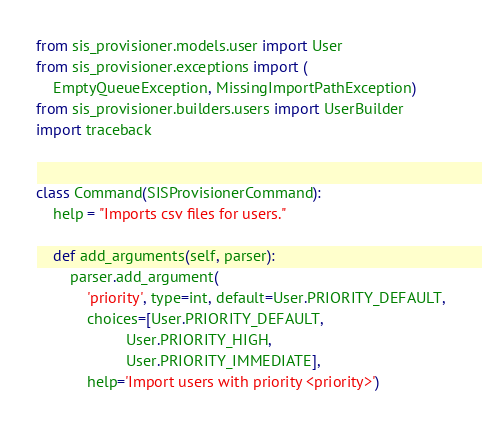<code> <loc_0><loc_0><loc_500><loc_500><_Python_>from sis_provisioner.models.user import User
from sis_provisioner.exceptions import (
    EmptyQueueException, MissingImportPathException)
from sis_provisioner.builders.users import UserBuilder
import traceback


class Command(SISProvisionerCommand):
    help = "Imports csv files for users."

    def add_arguments(self, parser):
        parser.add_argument(
            'priority', type=int, default=User.PRIORITY_DEFAULT,
            choices=[User.PRIORITY_DEFAULT,
                     User.PRIORITY_HIGH,
                     User.PRIORITY_IMMEDIATE],
            help='Import users with priority <priority>')
</code> 